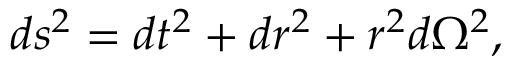<formula> <loc_0><loc_0><loc_500><loc_500>d s ^ { 2 } = d t ^ { 2 } + d r ^ { 2 } + r ^ { 2 } d \Omega ^ { 2 } ,</formula> 